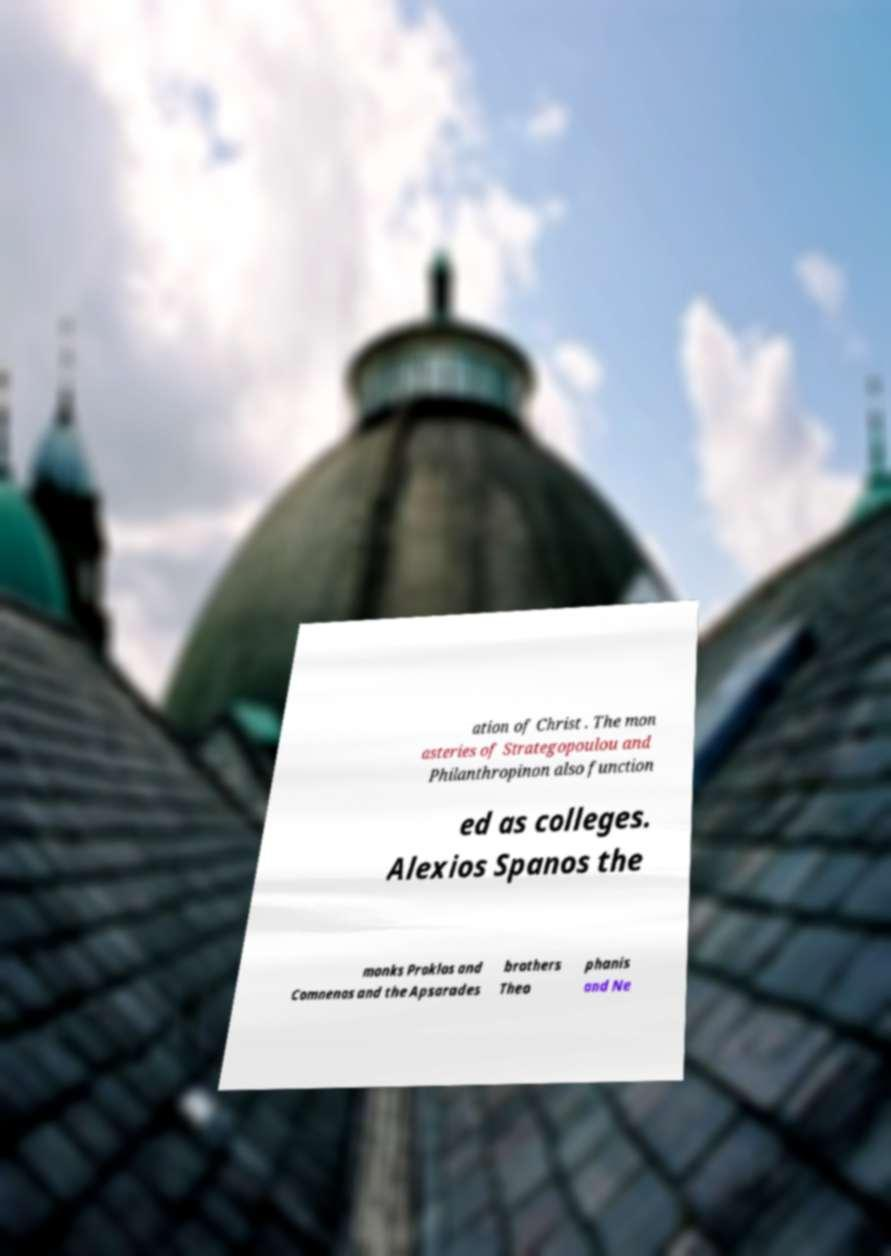Please identify and transcribe the text found in this image. ation of Christ . The mon asteries of Strategopoulou and Philanthropinon also function ed as colleges. Alexios Spanos the monks Proklos and Comnenos and the Apsarades brothers Theo phanis and Ne 